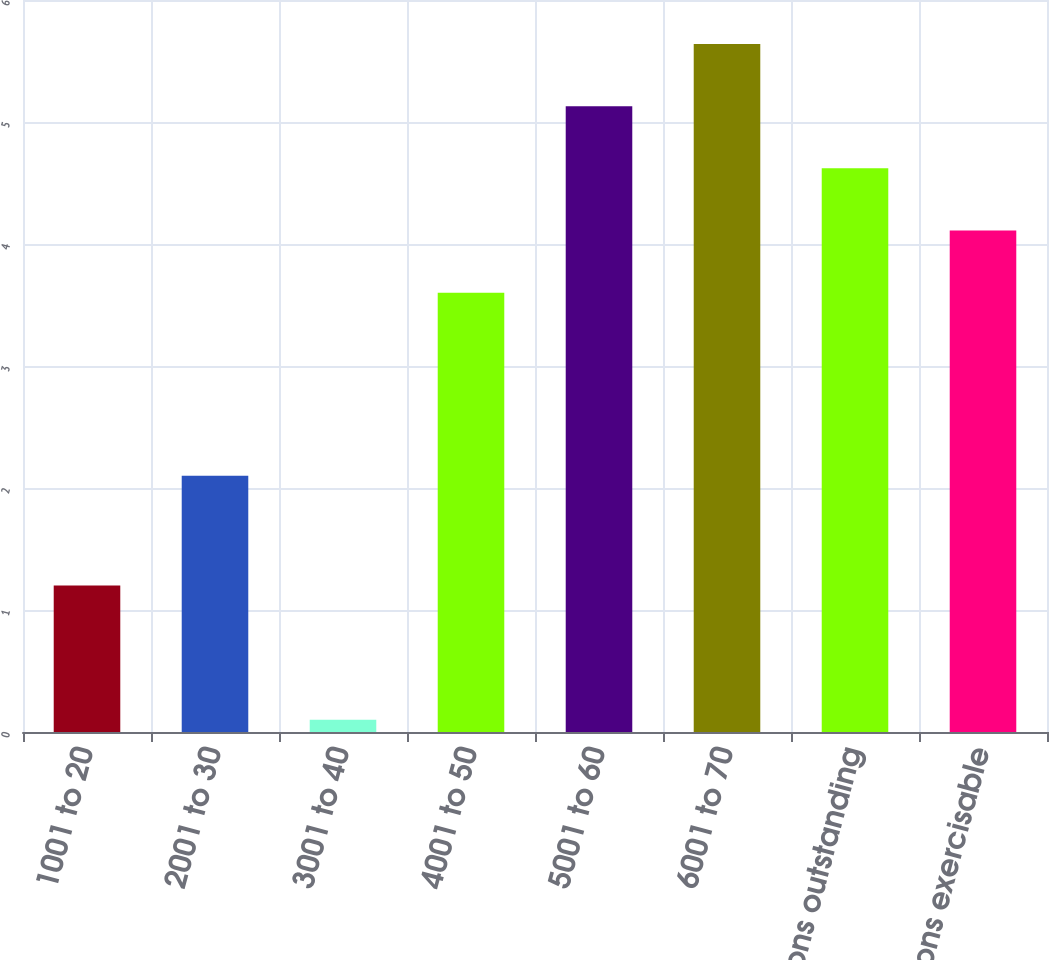Convert chart. <chart><loc_0><loc_0><loc_500><loc_500><bar_chart><fcel>1001 to 20<fcel>2001 to 30<fcel>3001 to 40<fcel>4001 to 50<fcel>5001 to 60<fcel>6001 to 70<fcel>Options outstanding<fcel>Options exercisable<nl><fcel>1.2<fcel>2.1<fcel>0.1<fcel>3.6<fcel>5.13<fcel>5.64<fcel>4.62<fcel>4.11<nl></chart> 